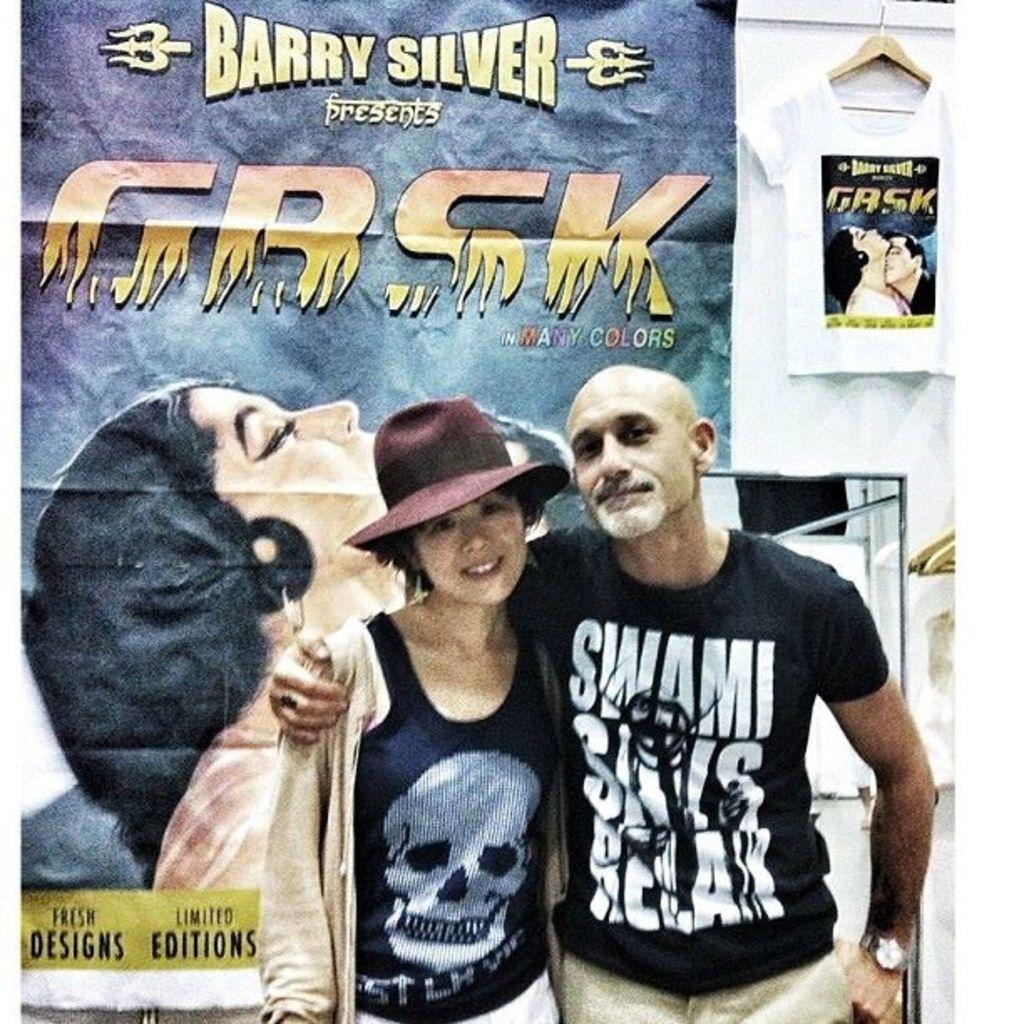How many people are present in the image? There are two persons in the image. What else can be seen in the image besides the people? There are posters and text visible in the image. What type of structure is present in the image? There is a building in the image. What is the total wealth of the persons in the image? There is no information about the wealth of the persons in the image. How many pigs are present in the image? There are no pigs present in the image. 